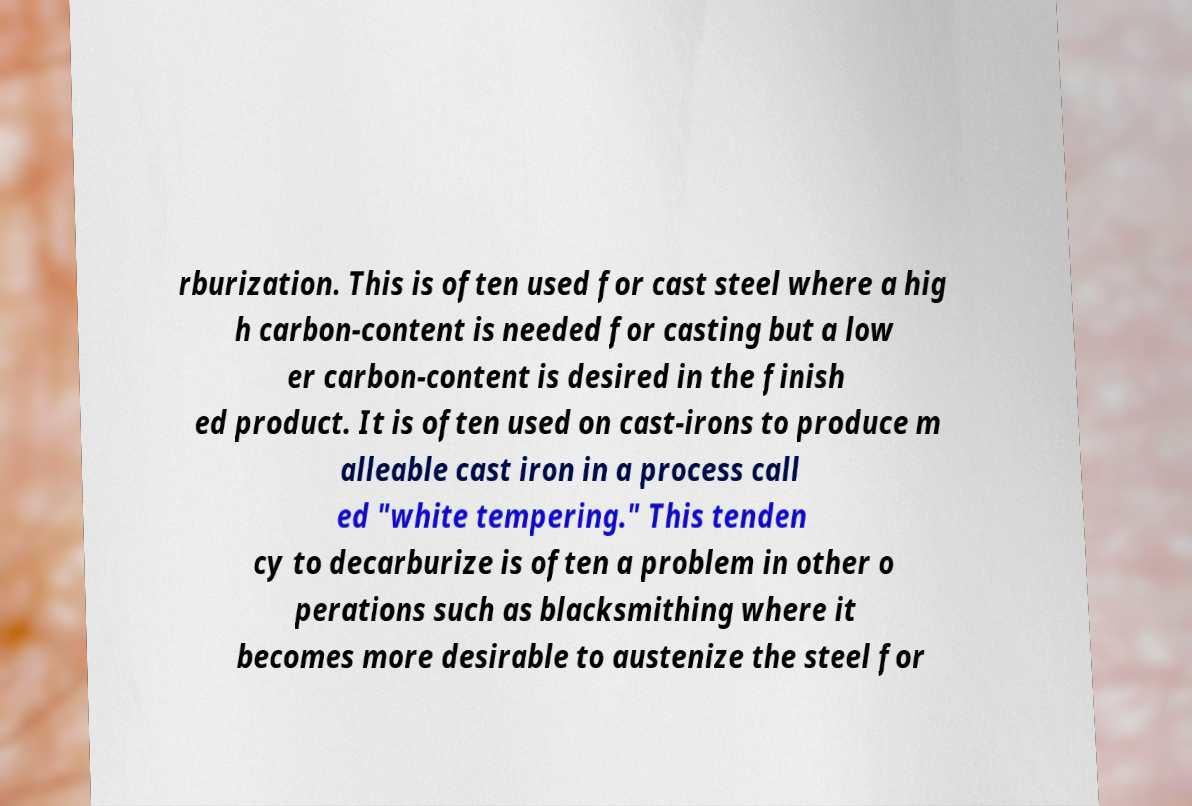Could you assist in decoding the text presented in this image and type it out clearly? rburization. This is often used for cast steel where a hig h carbon-content is needed for casting but a low er carbon-content is desired in the finish ed product. It is often used on cast-irons to produce m alleable cast iron in a process call ed "white tempering." This tenden cy to decarburize is often a problem in other o perations such as blacksmithing where it becomes more desirable to austenize the steel for 